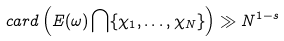Convert formula to latex. <formula><loc_0><loc_0><loc_500><loc_500>c a r d \left ( E ( \omega ) \bigcap \{ \chi _ { 1 } , \dots , \chi _ { N } \} \right ) \gg N ^ { 1 - s }</formula> 